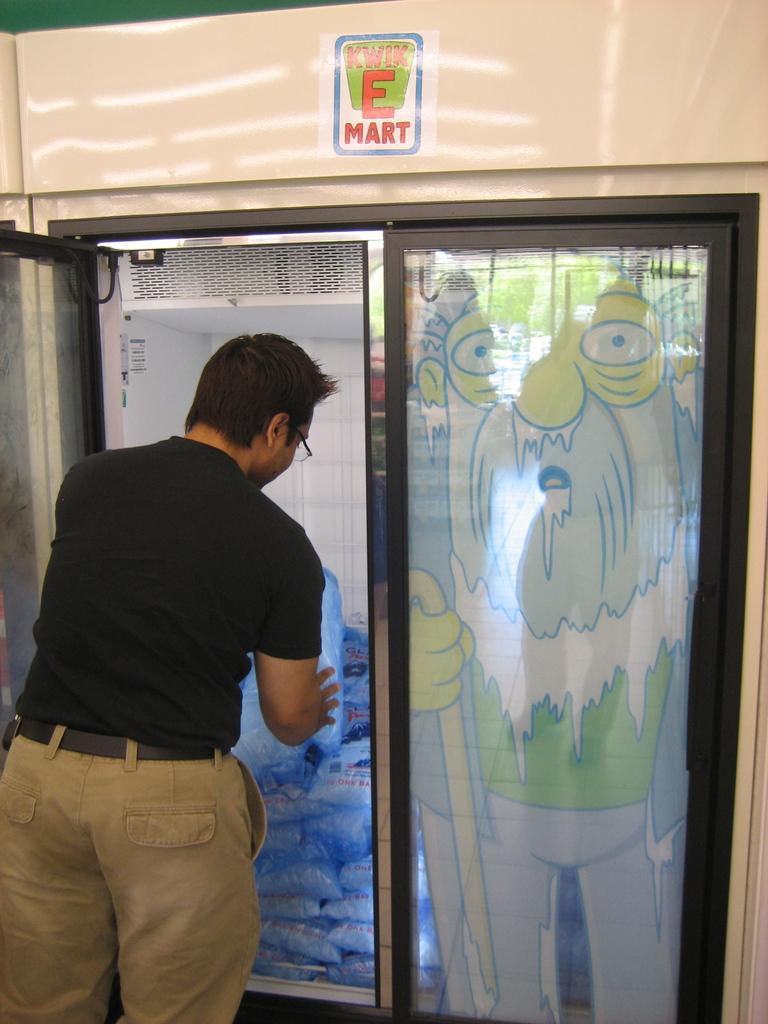<image>
Share a concise interpretation of the image provided. Man getting some ice from a fridge with a sign on top that says "Kwik E Mart". 